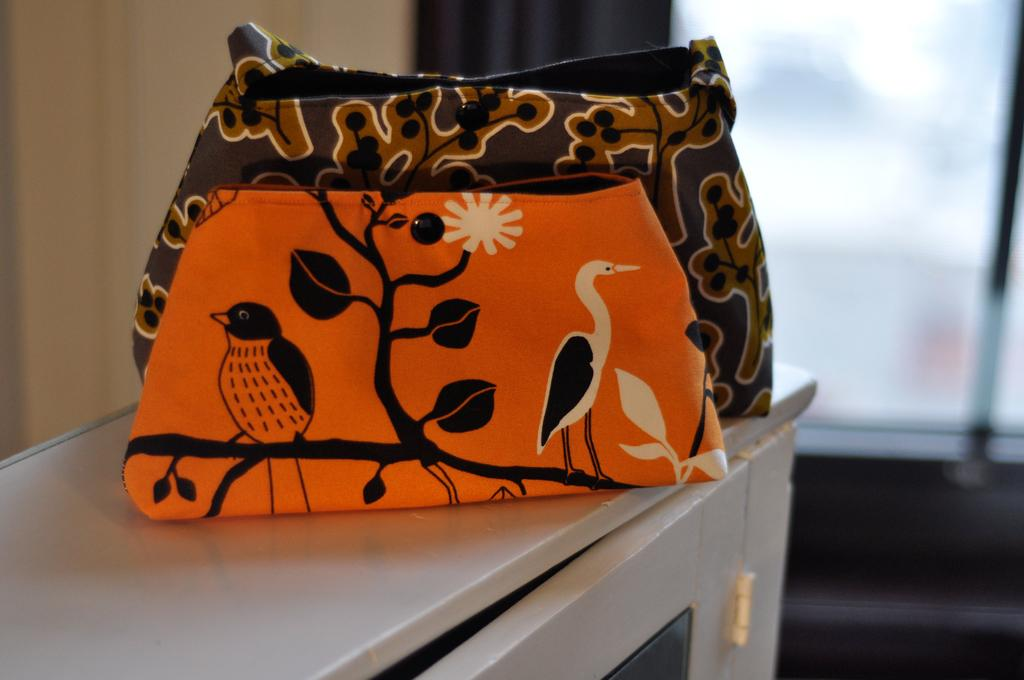How many bags are visible in the image? There are two bags in the image. Where are the bags located? The bags are placed on a table. What can be observed about the appearance of the bags? The bags are printed in different colors. What is the color of the table on which the bags are placed? The table is white in color. What type of tank is visible in the image? There is no tank present in the image. How many people are using the bags in the image? The image does not show any people using the bags, so it cannot be determined how many people are using them. 